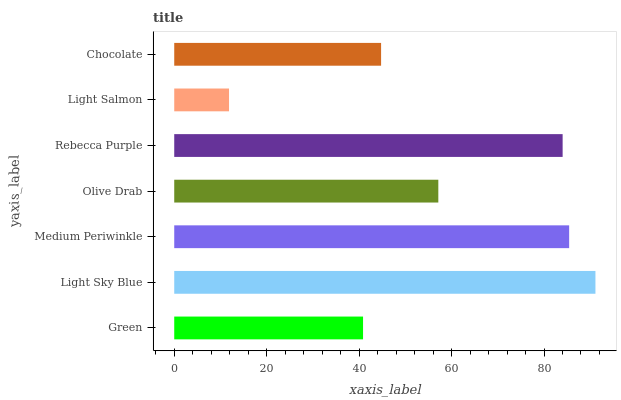Is Light Salmon the minimum?
Answer yes or no. Yes. Is Light Sky Blue the maximum?
Answer yes or no. Yes. Is Medium Periwinkle the minimum?
Answer yes or no. No. Is Medium Periwinkle the maximum?
Answer yes or no. No. Is Light Sky Blue greater than Medium Periwinkle?
Answer yes or no. Yes. Is Medium Periwinkle less than Light Sky Blue?
Answer yes or no. Yes. Is Medium Periwinkle greater than Light Sky Blue?
Answer yes or no. No. Is Light Sky Blue less than Medium Periwinkle?
Answer yes or no. No. Is Olive Drab the high median?
Answer yes or no. Yes. Is Olive Drab the low median?
Answer yes or no. Yes. Is Light Sky Blue the high median?
Answer yes or no. No. Is Rebecca Purple the low median?
Answer yes or no. No. 